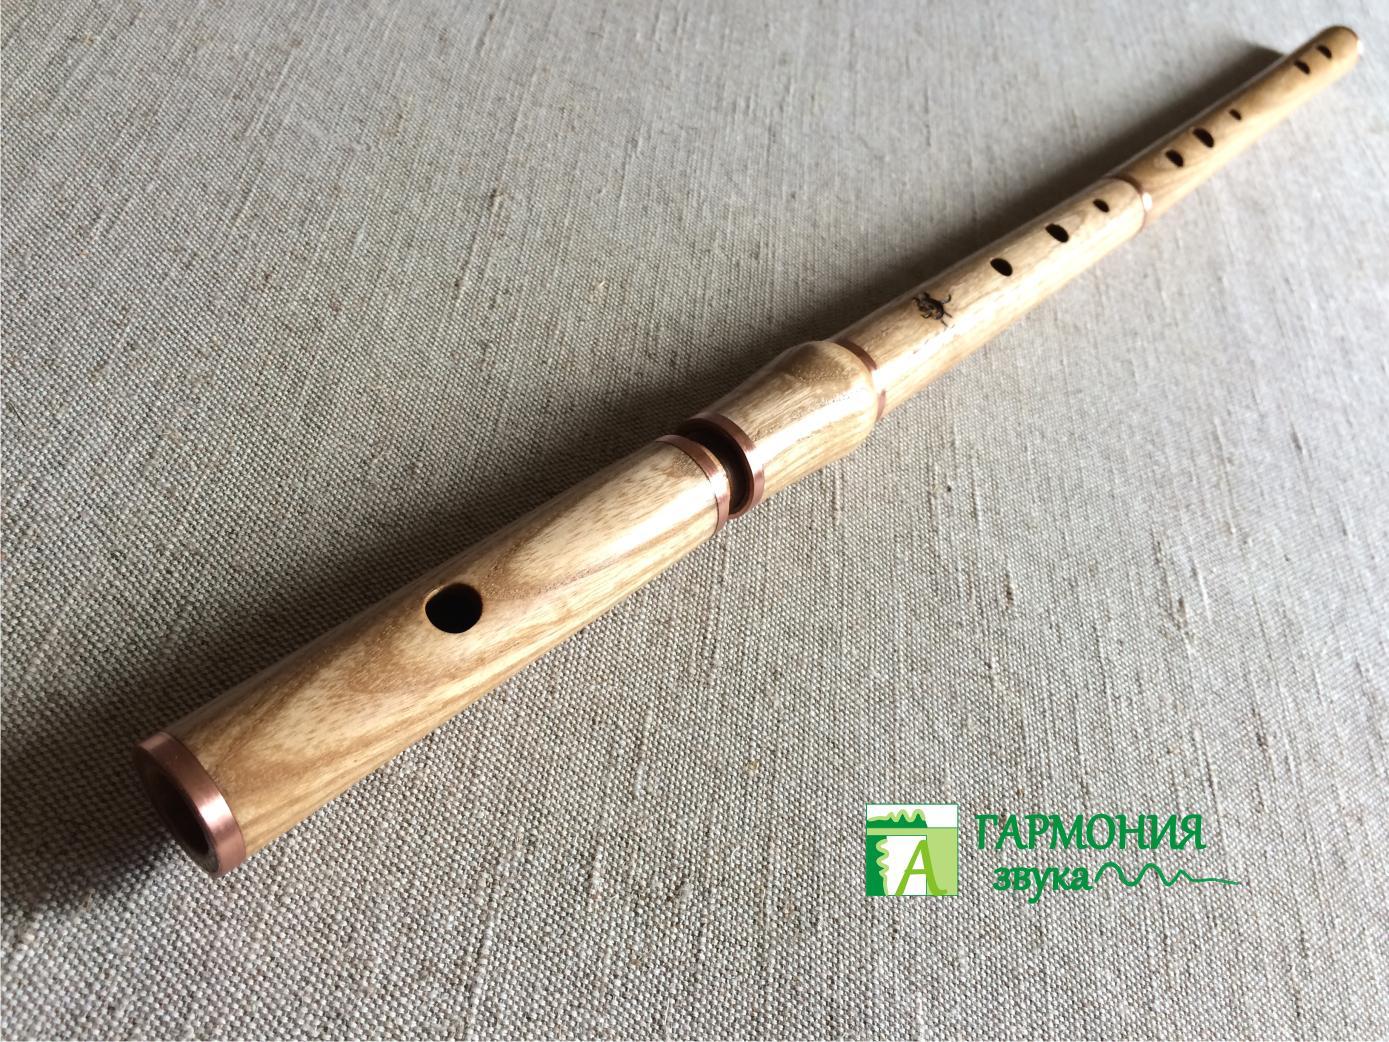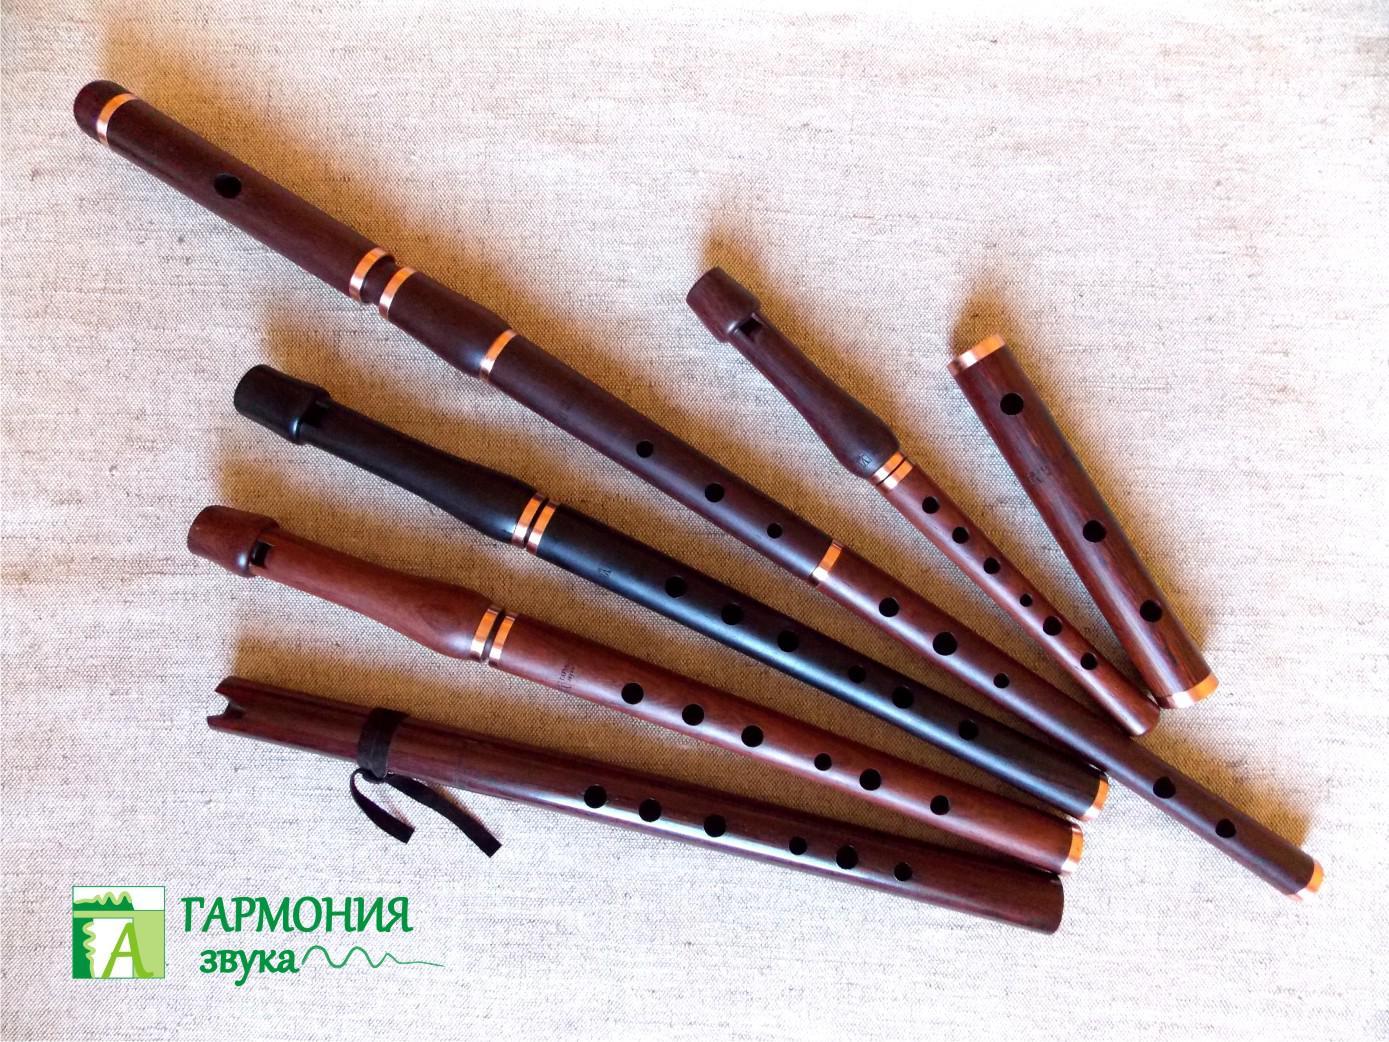The first image is the image on the left, the second image is the image on the right. Analyze the images presented: Is the assertion "The left image contains a single wooden flute displayed diagonally with one end at the upper right, and the right image features multiple flutes displayed diagonally at the opposite angle." valid? Answer yes or no. Yes. 